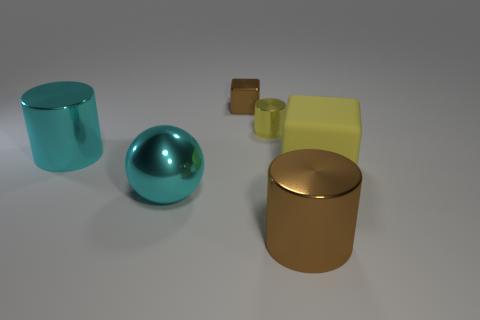Is there anything else that has the same color as the shiny ball?
Give a very brief answer. Yes. There is a metallic cylinder on the left side of the small brown metallic object; what size is it?
Provide a succinct answer. Large. There is a tiny metal cube; is it the same color as the cylinder that is in front of the matte object?
Give a very brief answer. Yes. How many other things are the same material as the cyan cylinder?
Ensure brevity in your answer.  4. Is the number of yellow rubber balls greater than the number of large rubber objects?
Provide a succinct answer. No. Do the big thing that is on the left side of the big ball and the matte block have the same color?
Offer a very short reply. No. What is the color of the matte block?
Keep it short and to the point. Yellow. There is a big metallic thing that is behind the yellow rubber block; is there a cyan metallic cylinder that is in front of it?
Give a very brief answer. No. What is the shape of the yellow thing behind the big shiny cylinder that is behind the large yellow thing?
Ensure brevity in your answer.  Cylinder. Are there fewer cyan shiny objects than tiny yellow things?
Your response must be concise. No. 